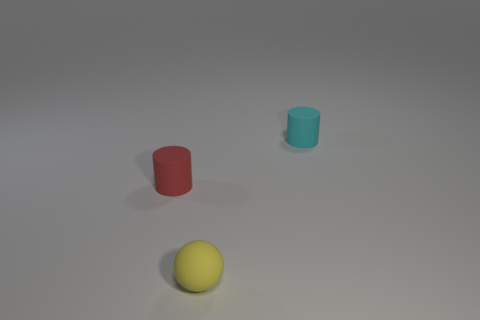Add 3 cylinders. How many objects exist? 6 Subtract 2 cylinders. How many cylinders are left? 0 Subtract all cylinders. How many objects are left? 1 Subtract all big red rubber things. Subtract all small things. How many objects are left? 0 Add 2 red cylinders. How many red cylinders are left? 3 Add 1 large red metal objects. How many large red metal objects exist? 1 Subtract 1 red cylinders. How many objects are left? 2 Subtract all gray cylinders. Subtract all yellow cubes. How many cylinders are left? 2 Subtract all cyan cylinders. How many purple balls are left? 0 